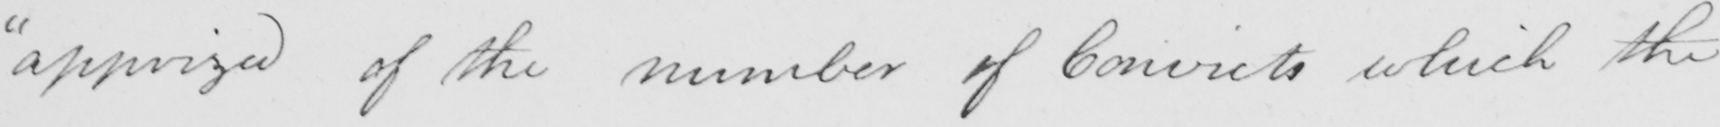Can you tell me what this handwritten text says? " apprized of the number of Convicts which the 